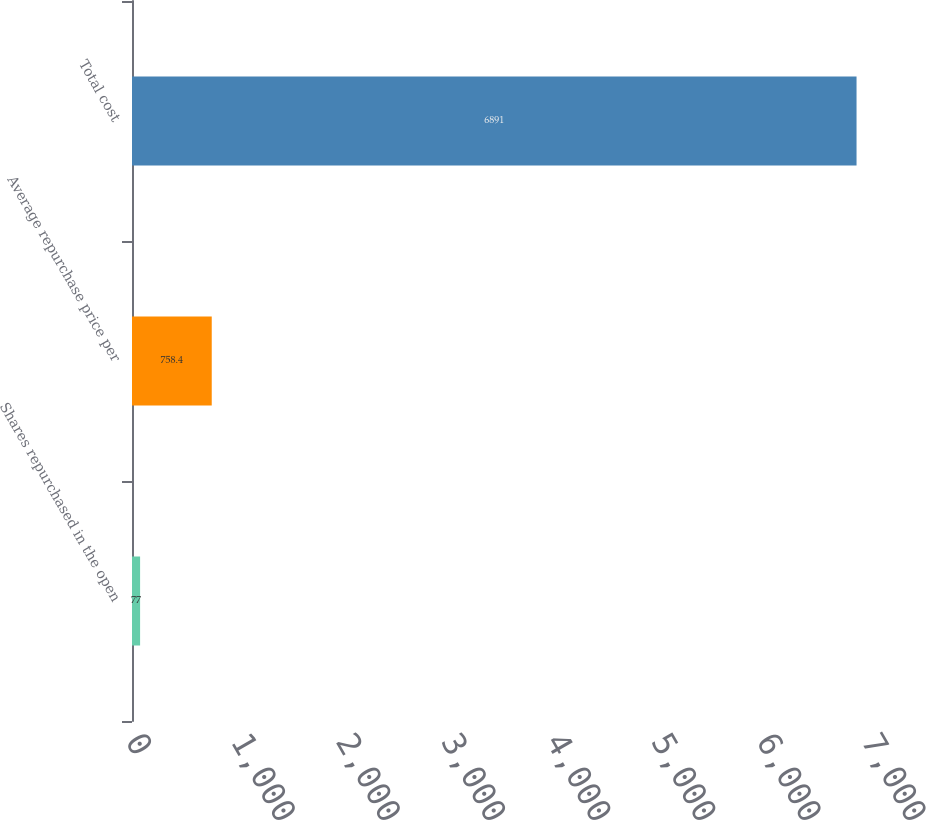<chart> <loc_0><loc_0><loc_500><loc_500><bar_chart><fcel>Shares repurchased in the open<fcel>Average repurchase price per<fcel>Total cost<nl><fcel>77<fcel>758.4<fcel>6891<nl></chart> 